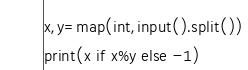<code> <loc_0><loc_0><loc_500><loc_500><_Python_>x,y=map(int,input().split())
print(x if x%y else -1)</code> 